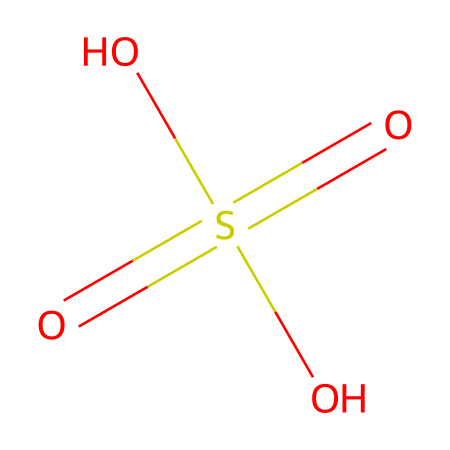What is the chemical name represented by this structure? The structure shows a central sulfur atom double-bonded to two oxygen atoms and single-bonded to two hydroxyl groups, which collectively indicate it is sulfuric acid.
Answer: sulfuric acid How many oxygen atoms are present in the structure? Analyzing the structure, there are four oxygen atoms: two in the double bonds and two in the hydroxyl groups.
Answer: four How many bonds does the sulfur atom form in this chemical? The sulfur atom forms a total of four bonds: two double bonds with oxygen and two single bonds with hydroxyl groups.
Answer: four What functional groups are present in this electrolyte? This structure contains hydroxyl (-OH) functional groups, which are indicative of acids and contribute to its acidic nature.
Answer: hydroxyl groups Explain why sulfuric acid is considered a strong acid? Sulfuric acid dissociates completely in water into sulfate anions and hydrogen ions, enhancing its acidity. The presence of more than one ionizable hydrogen and strong attraction to water also contributes to its strength.
Answer: dissociates completely What role do the hydroxyl groups play in the properties of sulfuric acid? The hydroxyl groups contribute to the acidic properties, allowing proton donation, which classifies sulfuric acid as an acid. They also participate in hydrogen bonding, influencing its solubility and reactivity.
Answer: acidic properties 